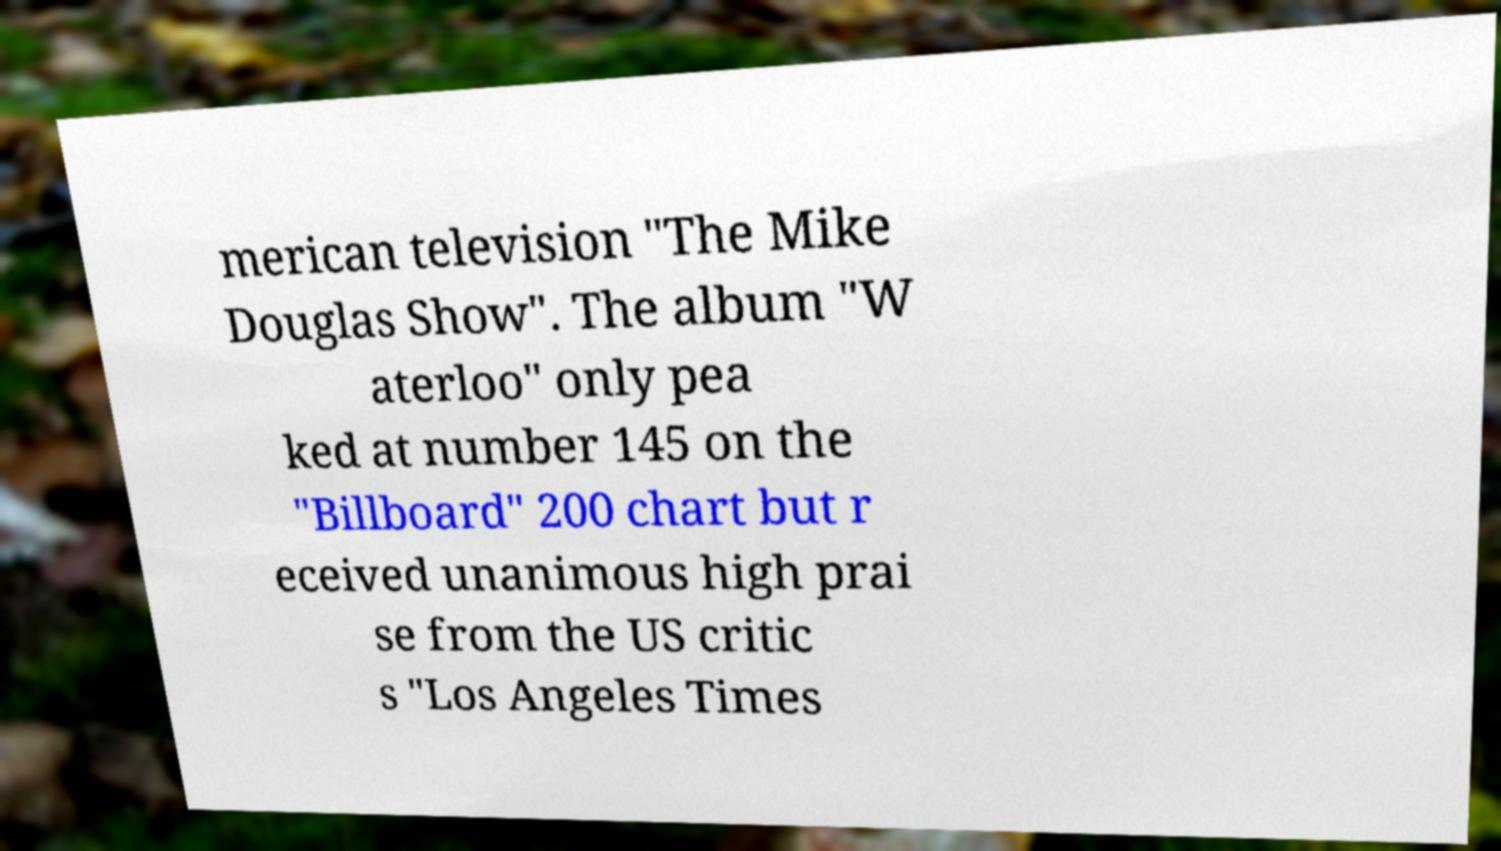Could you assist in decoding the text presented in this image and type it out clearly? merican television "The Mike Douglas Show". The album "W aterloo" only pea ked at number 145 on the "Billboard" 200 chart but r eceived unanimous high prai se from the US critic s "Los Angeles Times 